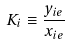Convert formula to latex. <formula><loc_0><loc_0><loc_500><loc_500>K _ { i } \equiv \frac { y _ { i e } } { x _ { i e } }</formula> 